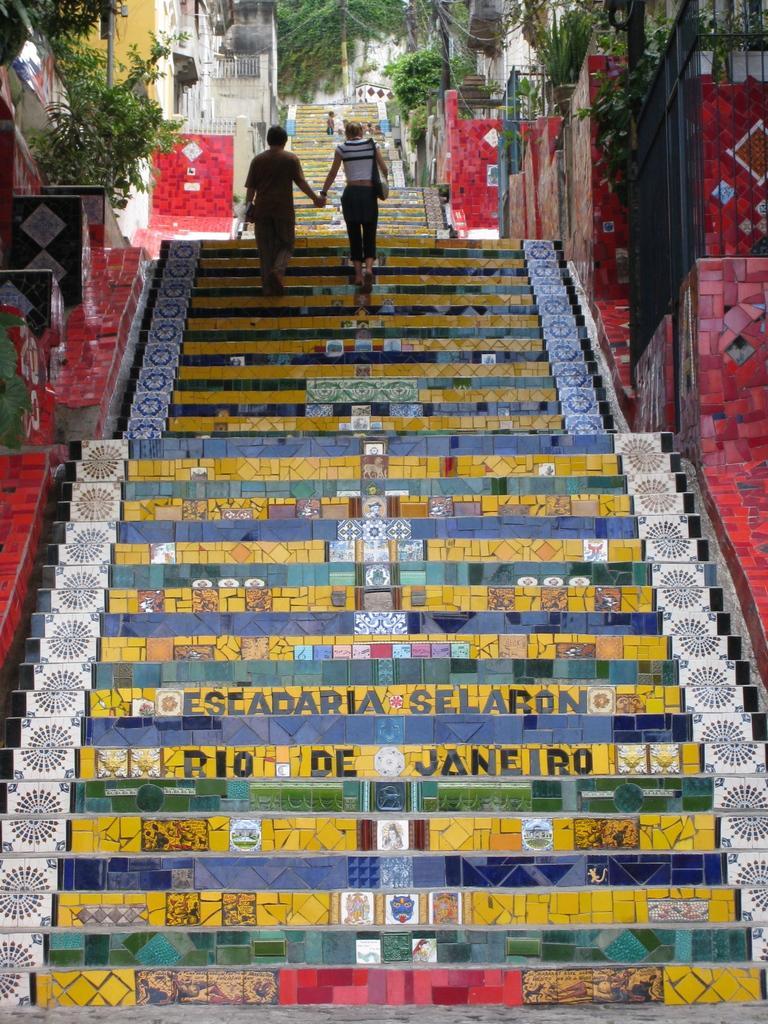Can you describe this image briefly? In the picture I can see steps which are yellow in color. In the background I can see plants, trees, buildings and people on steps. 